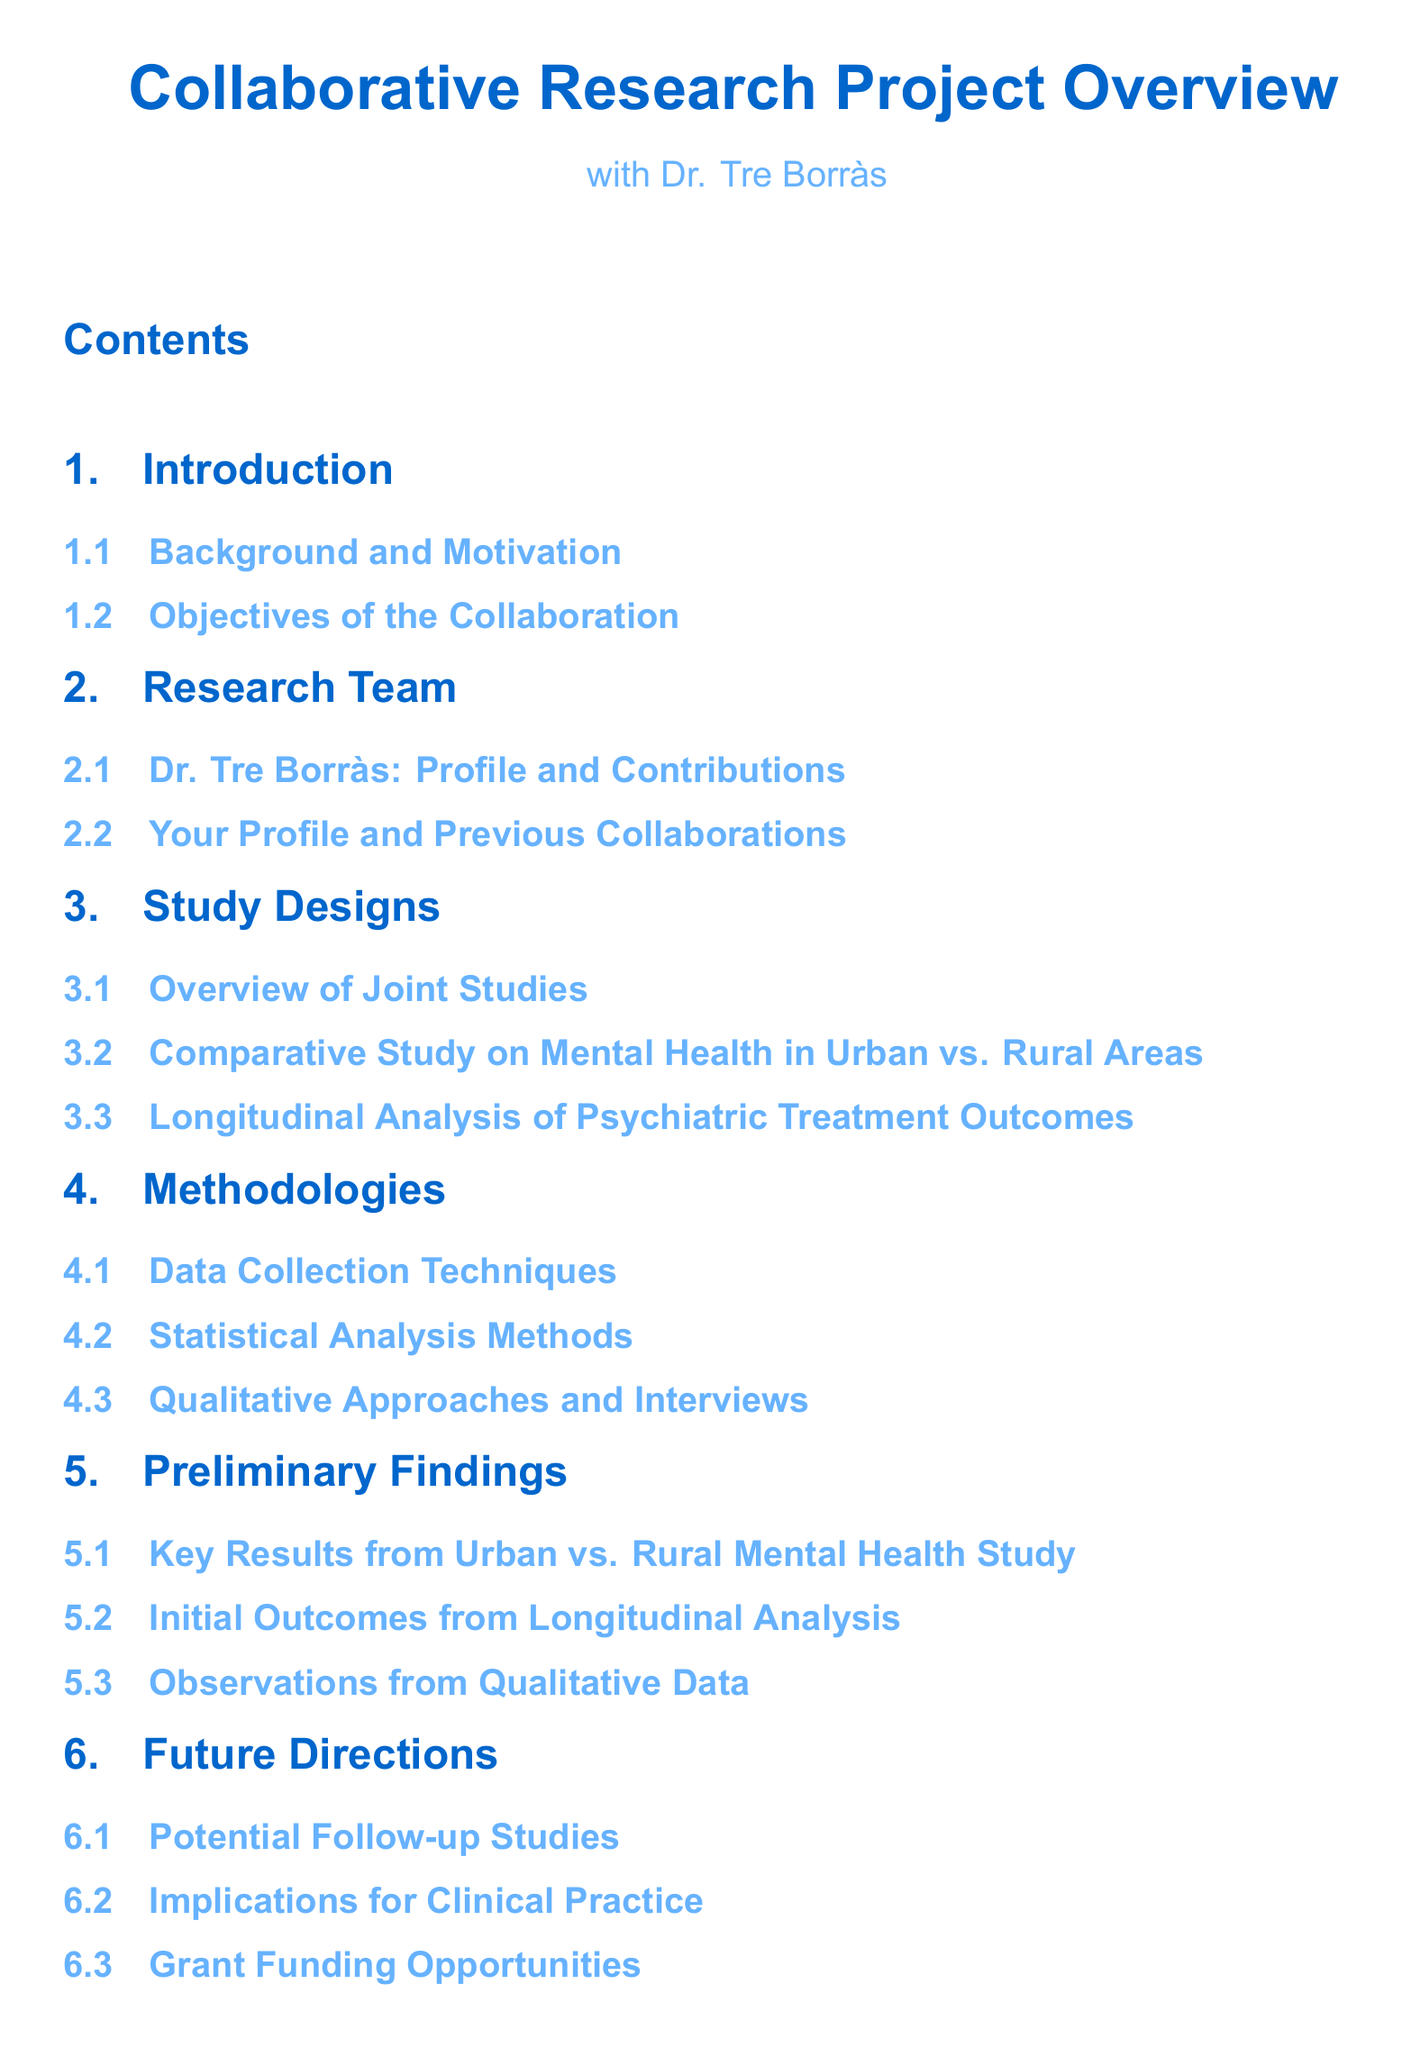What is the title of the document? The title is clearly stated at the beginning of the document, which is "Collaborative Research Project Overview".
Answer: Collaborative Research Project Overview Who is the co-author listed? The document mentions Dr. Tre Borràs in the subtitle as involved in the project.
Answer: Dr. Tre Borràs How many sections are in the document? The sections of the document include Introduction, Research Team, Study Designs, Methodologies, Preliminary Findings, Future Directions, and References, totaling seven sections.
Answer: 7 sections What type of analysis is discussed under Study Designs? One of the subsections discusses a "Longitudinal Analysis of Psychiatric Treatment Outcomes".
Answer: Longitudinal Analysis What method is mentioned under Methodologies for data collection? The document lists "Data Collection Techniques" as a subsection, indicating various methods for gathering research data.
Answer: Data Collection Techniques What are the two areas compared in the study? The study focuses on "Mental Health in Urban vs. Rural Areas".
Answer: Urban vs. Rural Areas What is one potential outcome listed in Future Directions? The document mentions "Implications for Clinical Practice" as a direction to consider for future studies.
Answer: Implications for Clinical Practice What type of study is included in the Study Designs section? The "Comparative Study on Mental Health" is a specified type of study within the section.
Answer: Comparative Study on Mental Health What is the format of the document? The document is structured as an academic overview with sections detailing various elements of the collaborative research project.
Answer: Article 